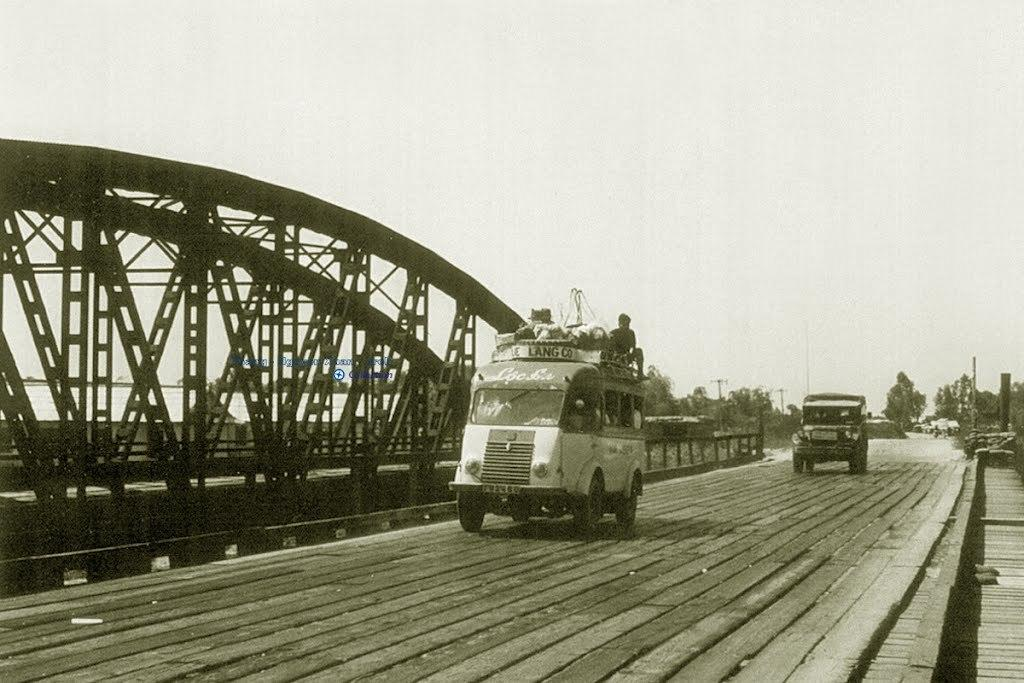What can be seen on the road in the image? There are vehicles on the road in the image. What structures are present with the rods in the image? There are arches with rods in the image. What is visible in the background of the image? The sky and trees are visible in the background of the image. Can you see any corn growing on the side of the road in the image? There is no corn visible in the image; it only features vehicles on the road, arches with rods, and the sky and trees in the background. Are there any chains hanging from the arches in the image? There is no mention of chains in the image; it only features arches with rods. 